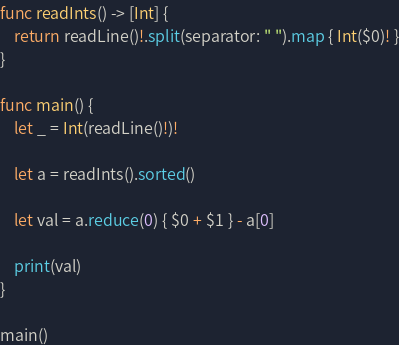<code> <loc_0><loc_0><loc_500><loc_500><_Swift_>func readInts() -> [Int] {
    return readLine()!.split(separator: " ").map { Int($0)! }
}

func main() {
    let _ = Int(readLine()!)!
    
    let a = readInts().sorted()
    
    let val = a.reduce(0) { $0 + $1 } - a[0]
    
    print(val)
}

main()
</code> 